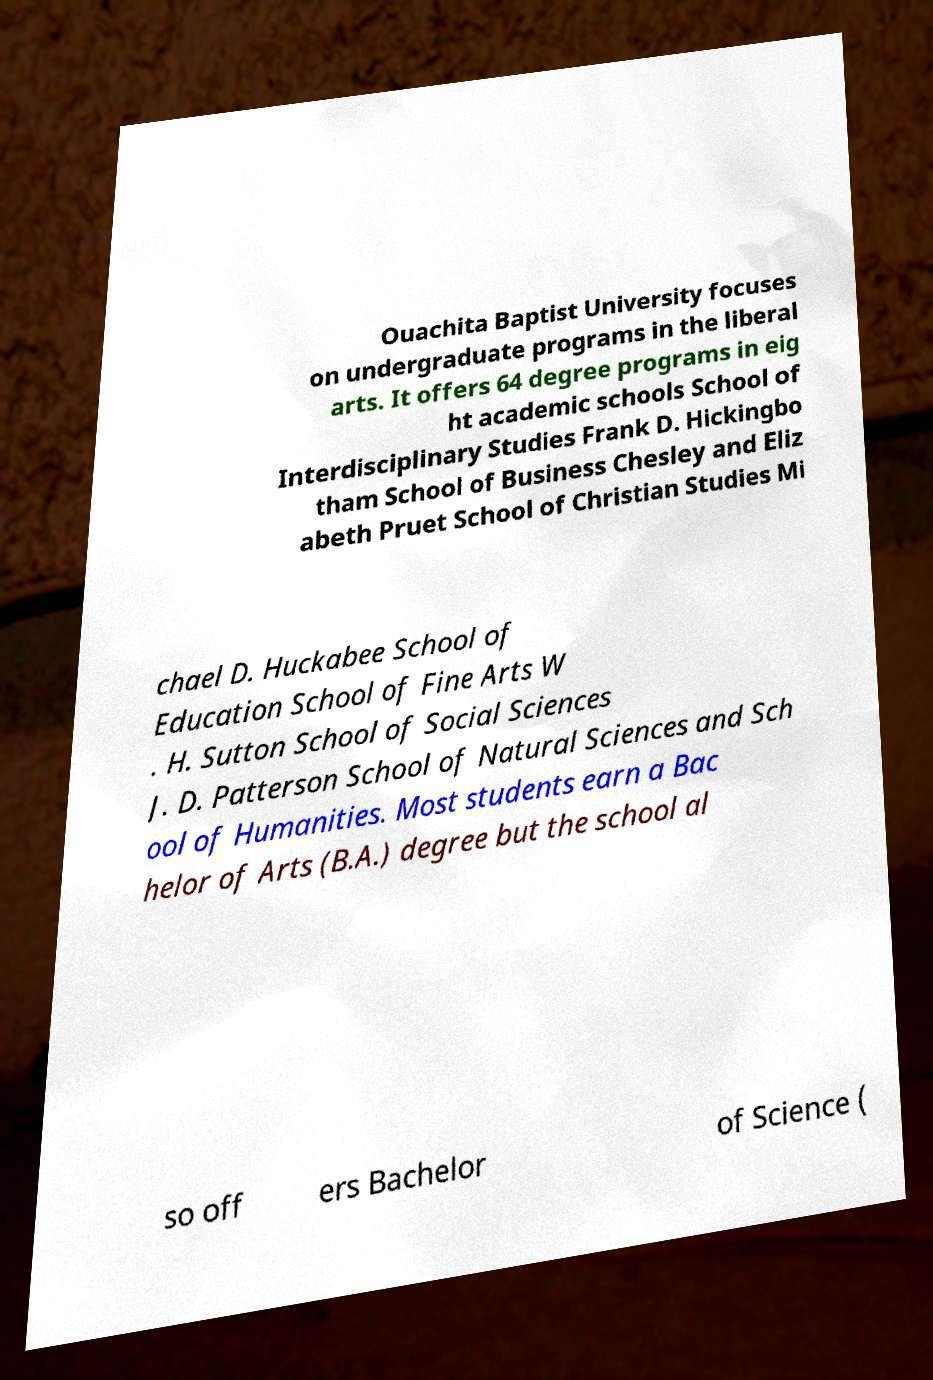Please read and relay the text visible in this image. What does it say? Ouachita Baptist University focuses on undergraduate programs in the liberal arts. It offers 64 degree programs in eig ht academic schools School of Interdisciplinary Studies Frank D. Hickingbo tham School of Business Chesley and Eliz abeth Pruet School of Christian Studies Mi chael D. Huckabee School of Education School of Fine Arts W . H. Sutton School of Social Sciences J. D. Patterson School of Natural Sciences and Sch ool of Humanities. Most students earn a Bac helor of Arts (B.A.) degree but the school al so off ers Bachelor of Science ( 